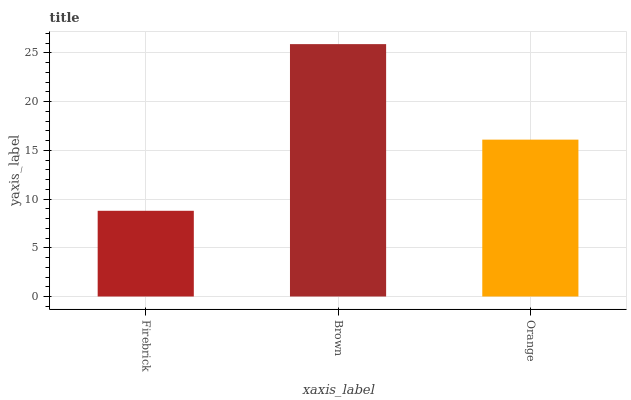Is Firebrick the minimum?
Answer yes or no. Yes. Is Brown the maximum?
Answer yes or no. Yes. Is Orange the minimum?
Answer yes or no. No. Is Orange the maximum?
Answer yes or no. No. Is Brown greater than Orange?
Answer yes or no. Yes. Is Orange less than Brown?
Answer yes or no. Yes. Is Orange greater than Brown?
Answer yes or no. No. Is Brown less than Orange?
Answer yes or no. No. Is Orange the high median?
Answer yes or no. Yes. Is Orange the low median?
Answer yes or no. Yes. Is Firebrick the high median?
Answer yes or no. No. Is Brown the low median?
Answer yes or no. No. 